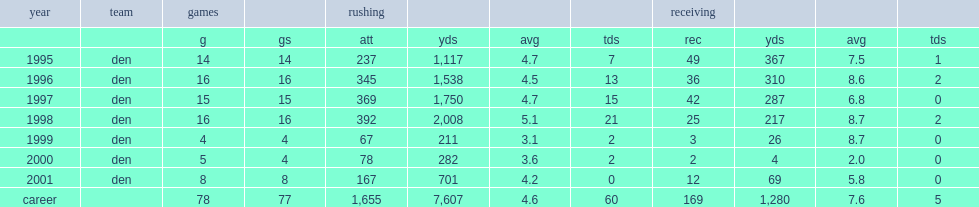How many rushing yards did davis finish his 1995 season with? 1117.0. 